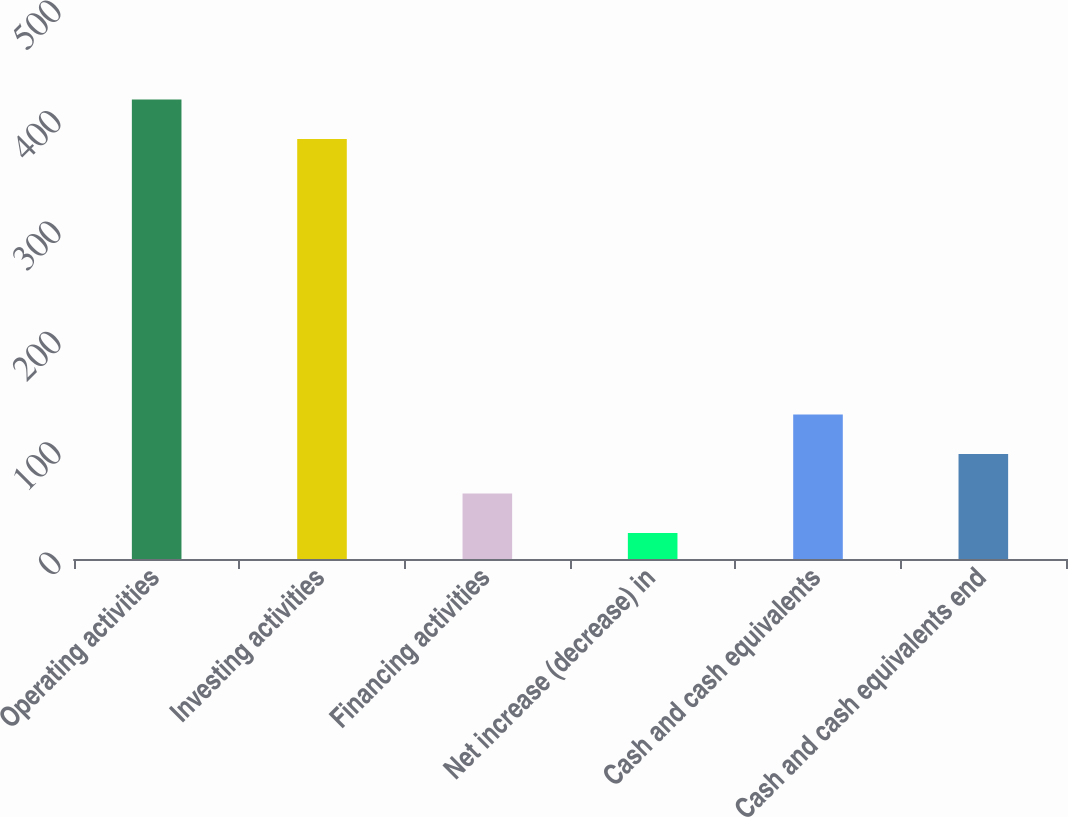Convert chart to OTSL. <chart><loc_0><loc_0><loc_500><loc_500><bar_chart><fcel>Operating activities<fcel>Investing activities<fcel>Financing activities<fcel>Net increase (decrease) in<fcel>Cash and cash equivalents<fcel>Cash and cash equivalents end<nl><fcel>416.3<fcel>380.5<fcel>59.3<fcel>23.5<fcel>130.9<fcel>95.1<nl></chart> 